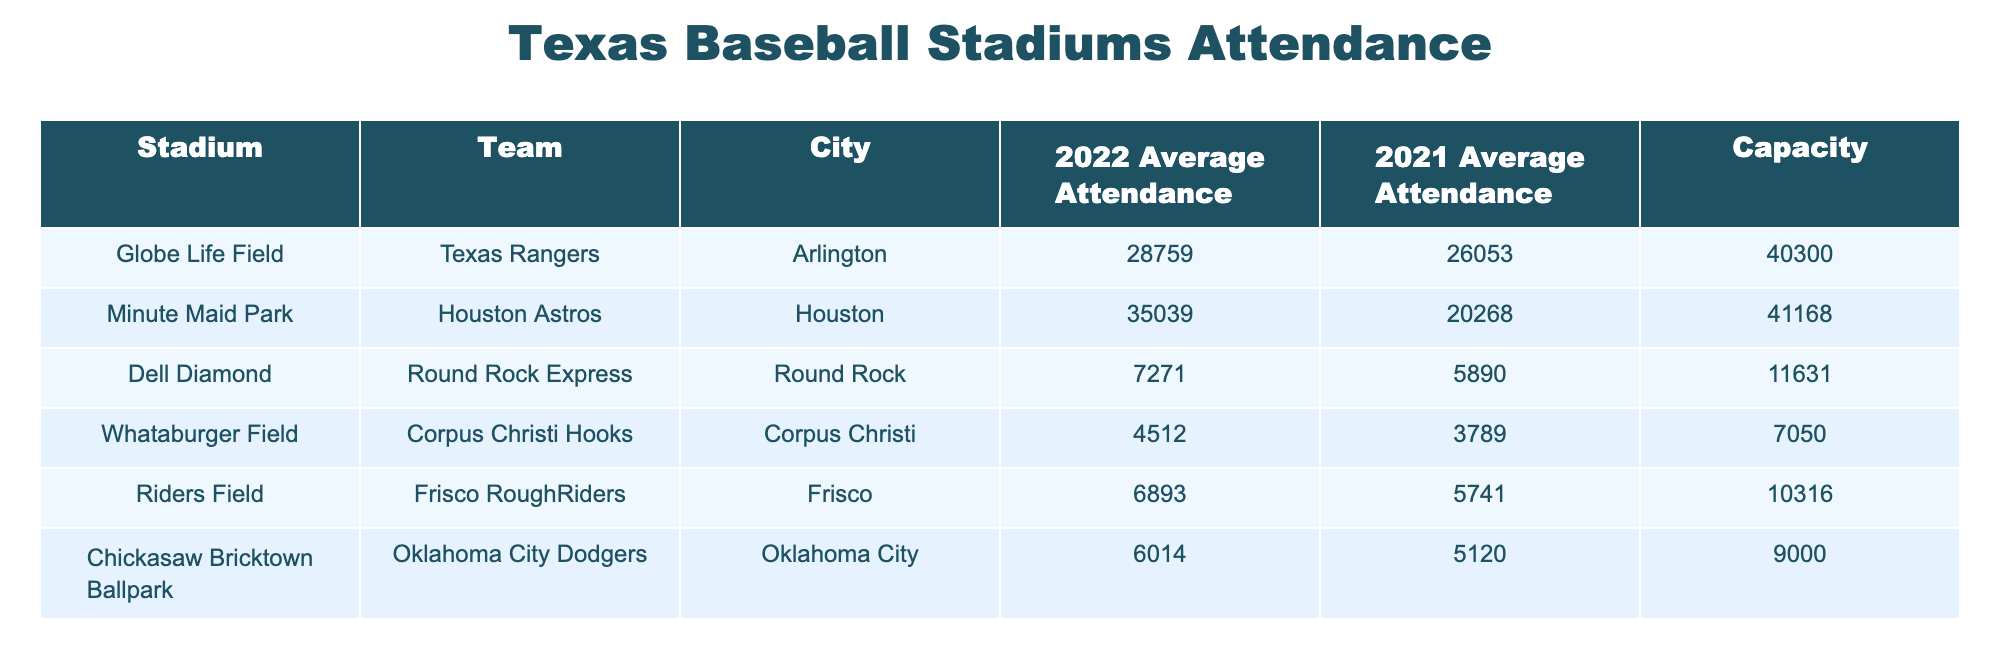What was the average attendance for the Texas Rangers in 2022? The table shows the 2022 average attendance for the Texas Rangers is 28759.
Answer: 28759 Which stadium had the highest average attendance in 2022? The highest average attendance in 2022 was at Minute Maid Park, with 35039.
Answer: Minute Maid Park What is the capacity of Globe Life Field? The capacity of Globe Life Field is listed as 40300 in the table.
Answer: 40300 Did the attendance for the Round Rock Express increase or decrease from 2021 to 2022? The attendance for the Round Rock Express increased from 5890 in 2021 to 7271 in 2022, showing an increase.
Answer: Increase What is the difference in average attendance between Minute Maid Park and Globe Life Field in 2022? For Minute Maid Park, the attendance is 35039, and for Globe Life Field, it is 28759. The difference is 35039 - 28759 = 6280.
Answer: 6280 Which team had the lowest average attendance in both 2021 and 2022? From the table, the team with the lowest average attendance in 2021 is the Corpus Christi Hooks with 3789, and in 2022, it is again the Corpus Christi Hooks with 4512.
Answer: Corpus Christi Hooks If we sum the 2022 average attendances of all teams listed, what do we get? The average attendances for the teams are: 28759 (Rangers) + 35039 (Astros) + 7271 (Express) + 4512 (Hooks) + 6893 (RoughRiders) + 6014 (Dodgers) = 82524.
Answer: 82524 Is the average attendance of the Frisco RoughRiders greater than 6000? The Frisco RoughRiders had an average attendance of 6893 in 2022, which is greater than 6000.
Answer: Yes What was the attendance trend (increase or decrease) for the Houston Astros from 2021 to 2022? The attendance for the Houston Astros increased from 20268 in 2021 to 35039 in 2022, indicating a positive trend.
Answer: Increase 